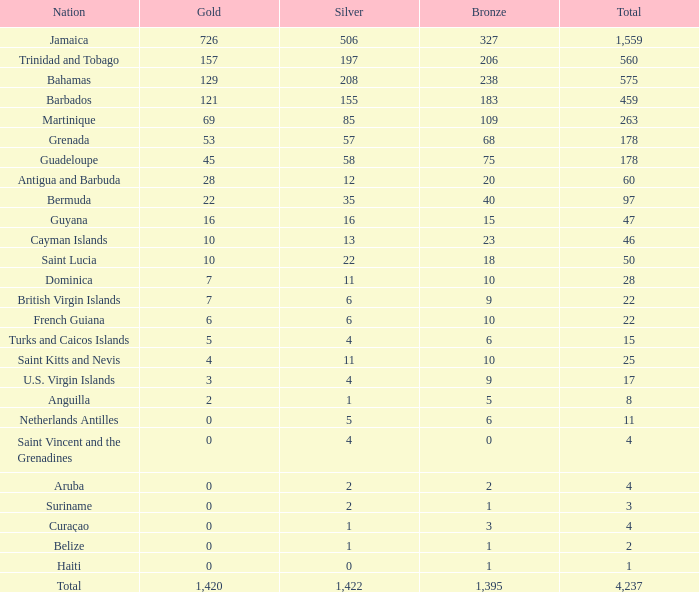Find the total sum of silver with a maximum of 559, a bronze minimum of 7, and a gold exactly 3. 4.0. 